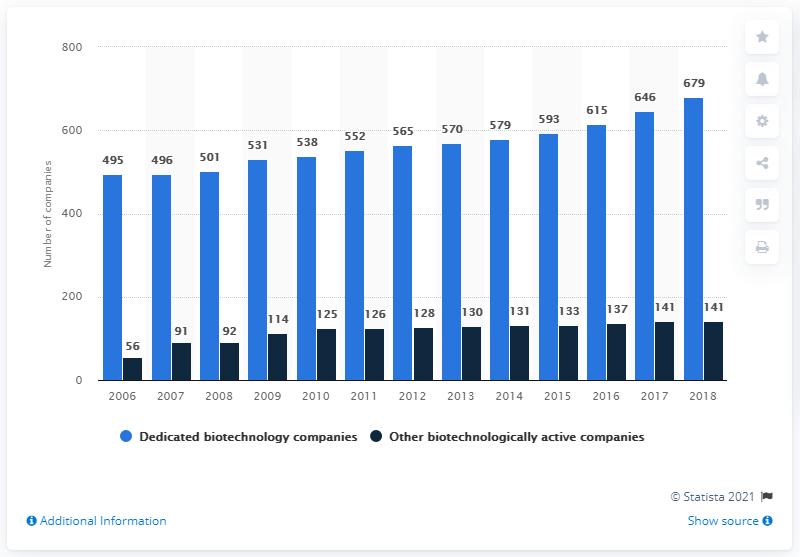Mention a couple of crucial points in this snapshot. In 2006, the year with the least value was. There were 141 other biotechnologically active companies in Germany in 2018. There were 679 dedicated biotechnology companies in Germany in 2018. The year with the greatest disparity between the mentioned companies is 2018. 